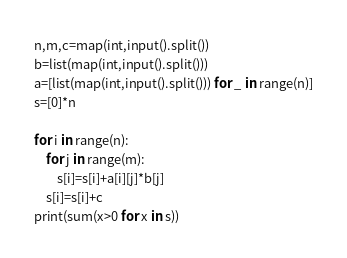<code> <loc_0><loc_0><loc_500><loc_500><_Python_>n,m,c=map(int,input().split())
b=list(map(int,input().split()))
a=[list(map(int,input().split())) for _ in range(n)]
s=[0]*n

for i in range(n):
    for j in range(m):
        s[i]=s[i]+a[i][j]*b[j]
    s[i]=s[i]+c
print(sum(x>0 for x in s))</code> 